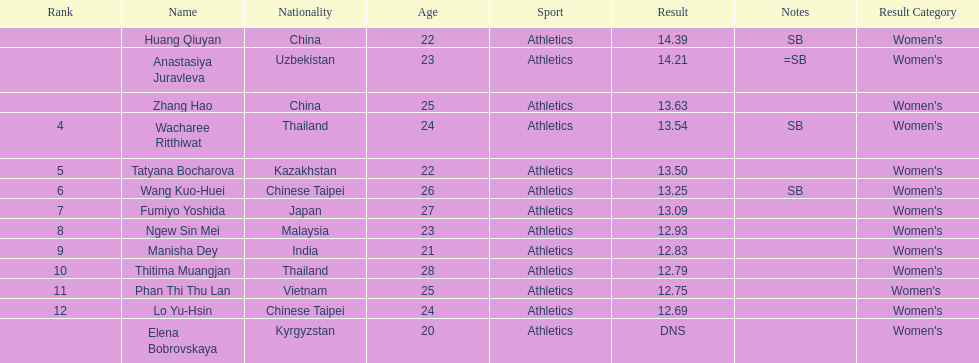How many contestants were from thailand? 2. 